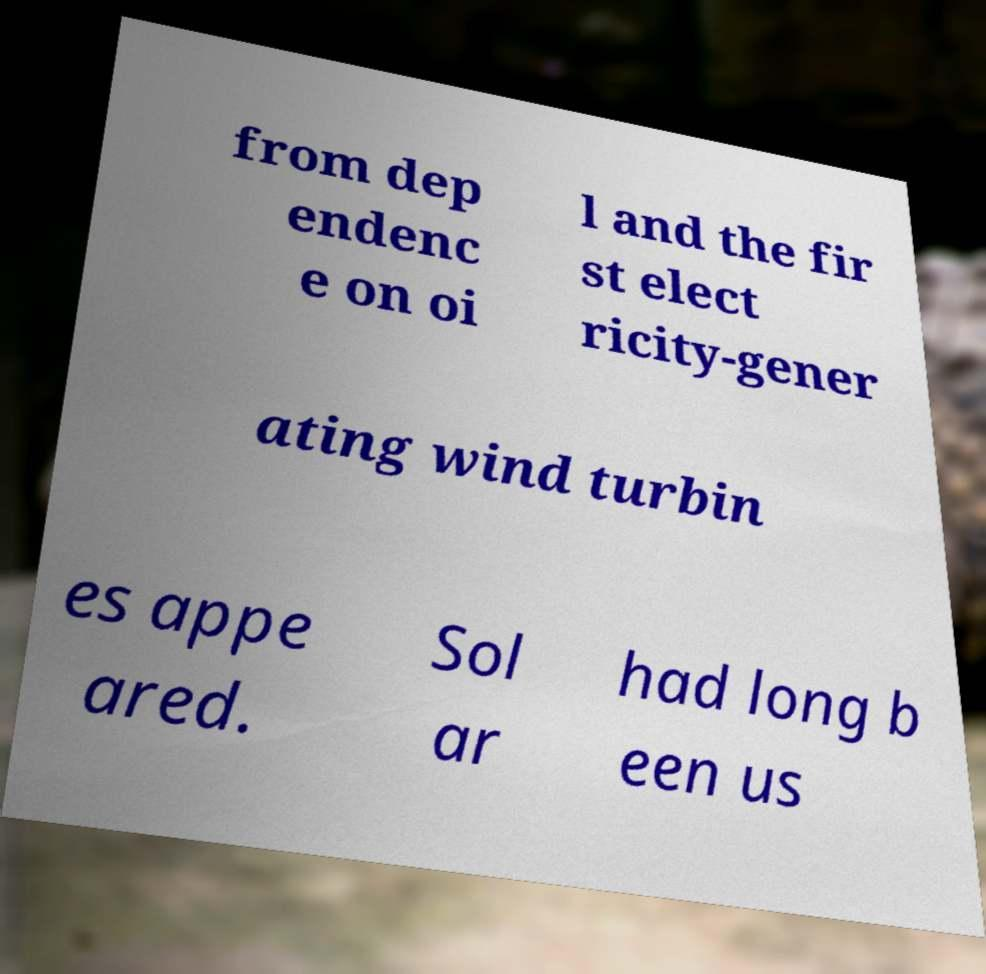There's text embedded in this image that I need extracted. Can you transcribe it verbatim? from dep endenc e on oi l and the fir st elect ricity-gener ating wind turbin es appe ared. Sol ar had long b een us 